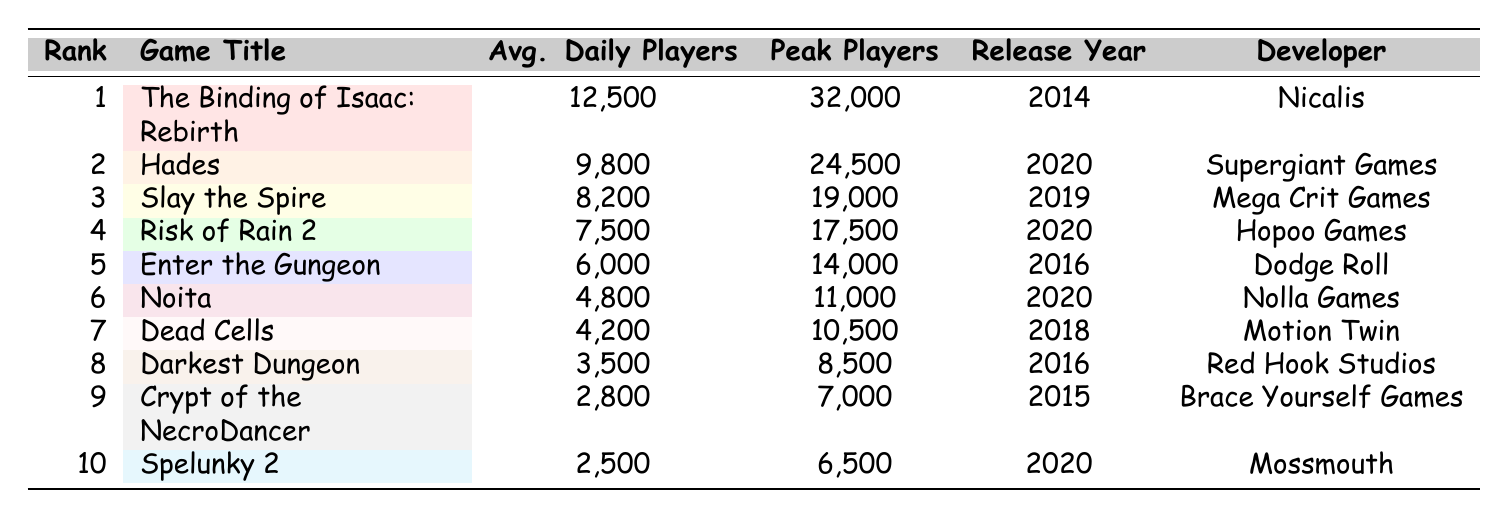What is the game with the highest average daily players? The game with the highest average daily players can be found in the "Avg. Daily Players" column. The top entry is "The Binding of Isaac: Rebirth" with 12,500 average daily players.
Answer: The Binding of Isaac: Rebirth Which game was released in 2016? By looking at the "Release Year" column, "Enter the Gungeon" and "Darkest Dungeon" are the only two games listed with the release year of 2016.
Answer: Enter the Gungeon, Darkest Dungeon What is the difference in peak player count between "Hades" and "Noita"? To find the difference, look at the "Peak Players" column for both games. Hades has 24,500 peak players and Noita has 11,000 peak players. The difference is 24,500 - 11,000 = 13,500.
Answer: 13,500 Is "Dead Cells" ranked higher than "Enter the Gungeon"? To determine this, compare their ranks in the "Rank" column. "Dead Cells" is ranked 7th while "Enter the Gungeon" is ranked 5th, meaning "Dead Cells" is not ranked higher than "Enter the Gungeon".
Answer: No What is the average number of peak players for games released in 2020? The games released in 2020 are "Hades," "Risk of Rain 2," "Noita," and "Spelunky 2." Their peak players are 24,500, 17,500, 11,000, and 6,500, respectively. Summing these gives 24,500 + 17,500 + 11,000 + 6,500 = 59,500. Dividing by 4 gives an average of 59,500 / 4 = 14,875.
Answer: 14,875 